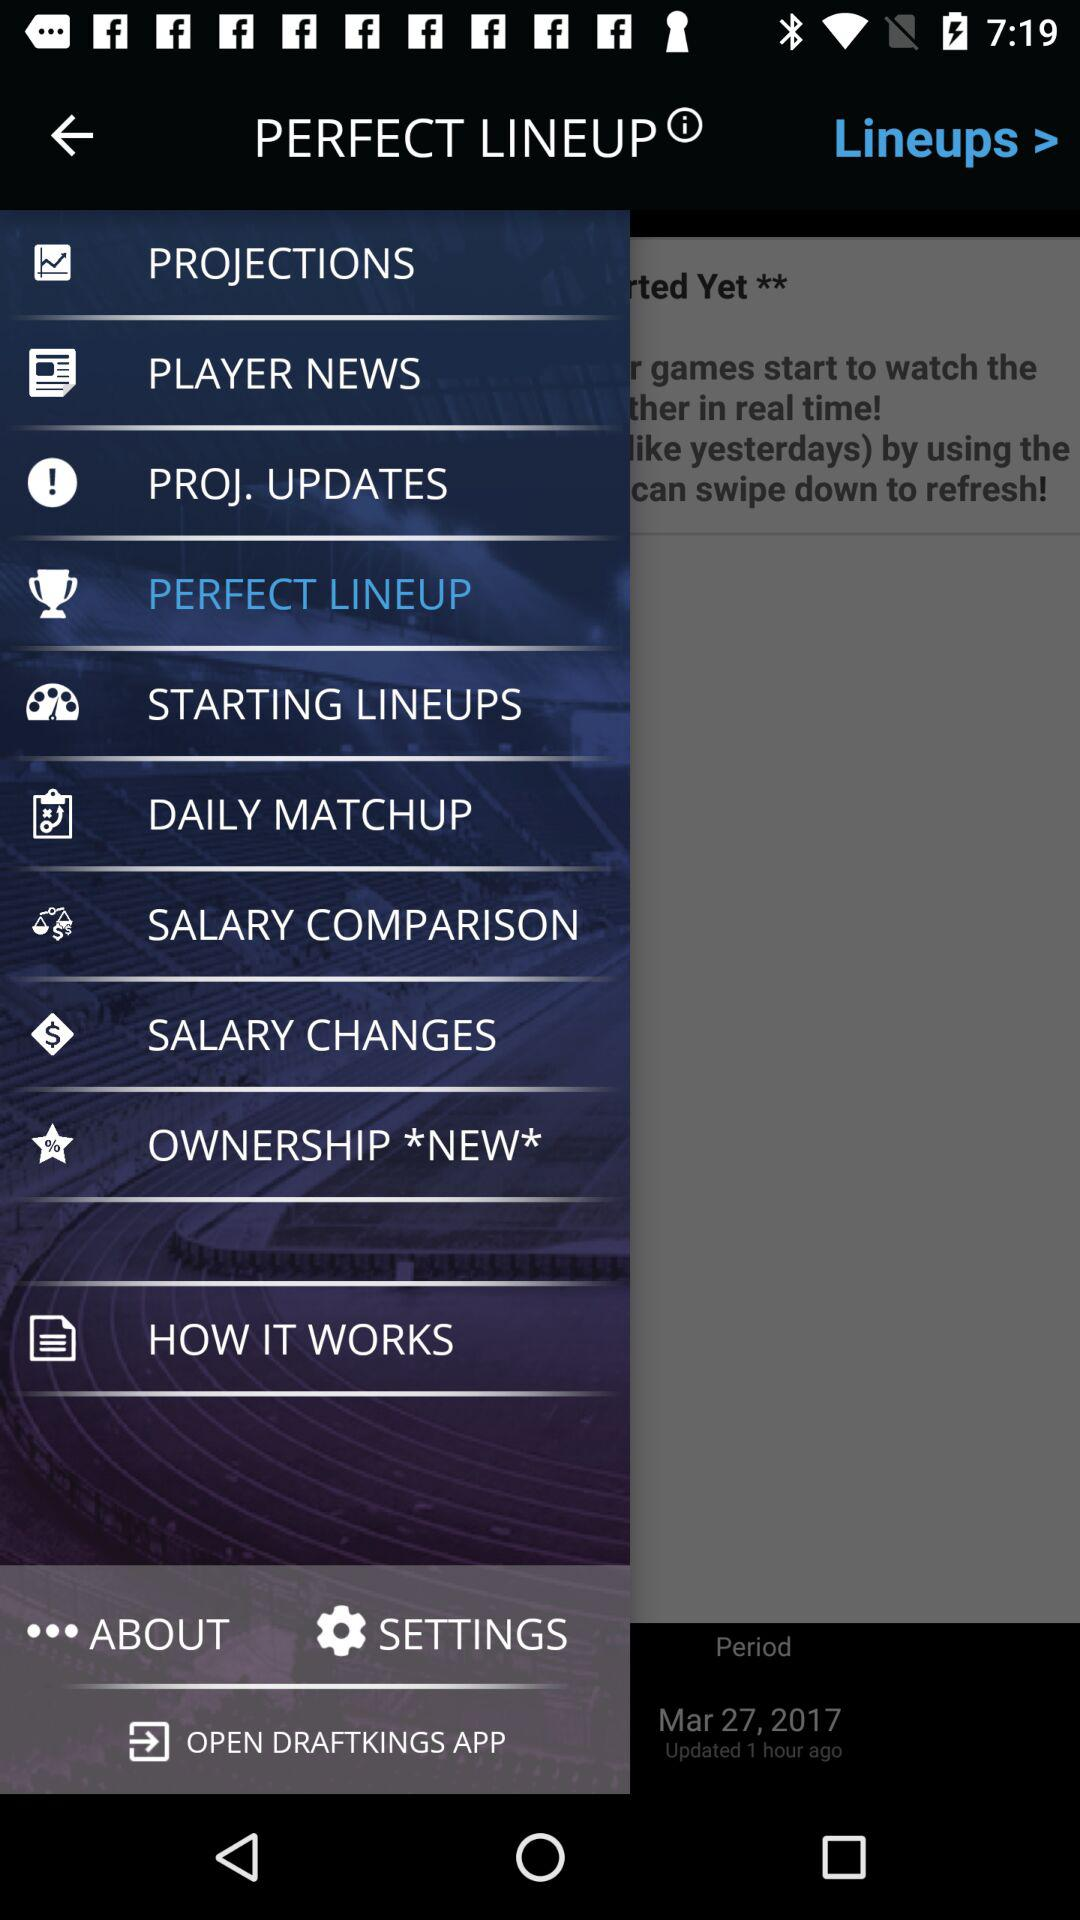When was the application updated? The application was last updated 1 hour ago. 